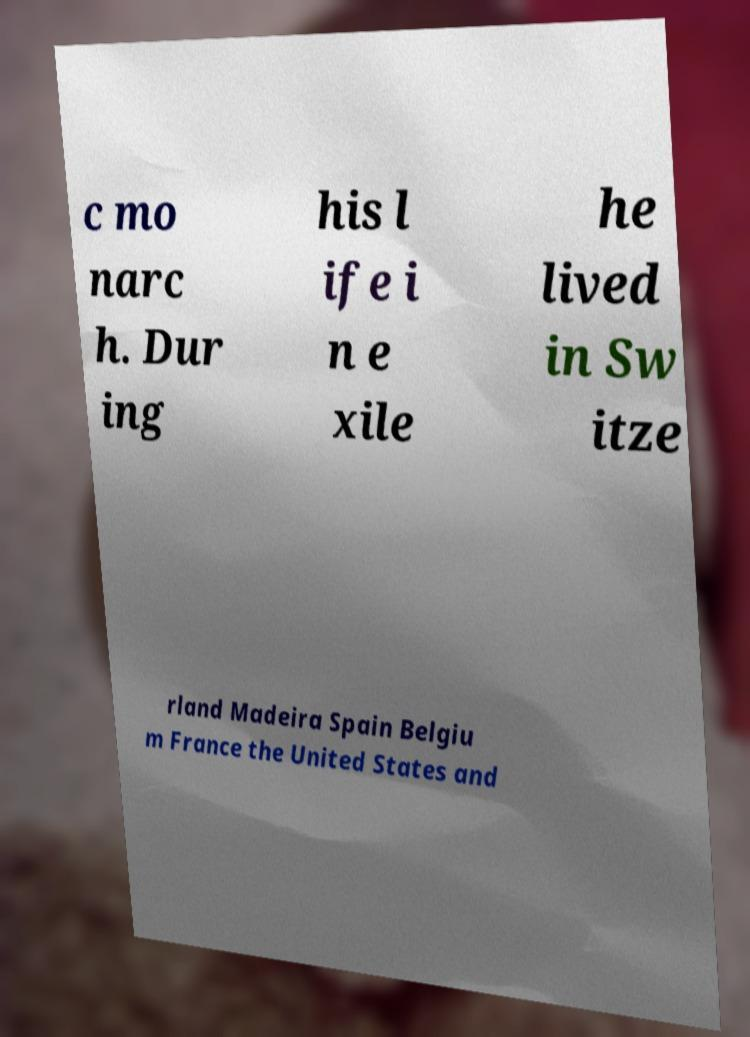Could you extract and type out the text from this image? c mo narc h. Dur ing his l ife i n e xile he lived in Sw itze rland Madeira Spain Belgiu m France the United States and 